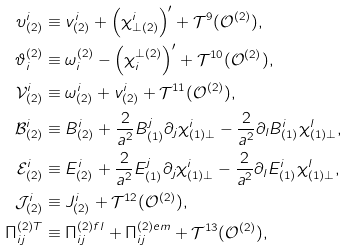Convert formula to latex. <formula><loc_0><loc_0><loc_500><loc_500>\upsilon _ { ( 2 ) } ^ { i } & \equiv v _ { ( 2 ) } ^ { i } + \left ( \chi _ { \bot ( 2 ) } ^ { i } \right ) ^ { \prime } + \mathcal { T } ^ { 9 } ( \mathcal { O } ^ { ( 2 ) } ) , \\ \vartheta _ { i } ^ { ( 2 ) } & \equiv \omega _ { i } ^ { ( 2 ) } - \left ( \chi _ { i } ^ { \bot ( 2 ) } \right ) ^ { \prime } + \mathcal { T } ^ { 1 0 } ( \mathcal { O } ^ { ( 2 ) } ) , \\ \mathcal { V } _ { ( 2 ) } ^ { i } & \equiv \omega _ { ( 2 ) } ^ { i } + v _ { ( 2 ) } ^ { i } + \mathcal { T } ^ { 1 1 } ( \mathcal { O } ^ { ( 2 ) } ) , \\ \mathcal { B } _ { ( 2 ) } ^ { i } & \equiv B _ { ( 2 ) } ^ { i } + \frac { 2 } { a ^ { 2 } } B _ { ( 1 ) } ^ { j } \partial _ { j } \chi _ { ( 1 ) \bot } ^ { i } - \frac { 2 } { a ^ { 2 } } \partial _ { l } B _ { ( 1 ) } ^ { i } \chi _ { ( 1 ) \bot } ^ { l } , \\ \mathcal { E } _ { ( 2 ) } ^ { i } & \equiv E _ { ( 2 ) } ^ { i } + \frac { 2 } { a ^ { 2 } } E _ { ( 1 ) } ^ { j } \partial _ { j } \chi _ { ( 1 ) \bot } ^ { i } - \frac { 2 } { a ^ { 2 } } \partial _ { l } E _ { ( 1 ) } ^ { i } \chi _ { ( 1 ) \bot } ^ { l } , \\ \mathcal { J } _ { ( 2 ) } ^ { i } & \equiv J _ { ( 2 ) } ^ { i } + \mathcal { T } ^ { 1 2 } ( \mathcal { O } ^ { ( 2 ) } ) , \\ \Pi _ { i j } ^ { ( 2 ) T } & \equiv \Pi _ { i j } ^ { ( 2 ) f l } + \Pi _ { i j } ^ { ( 2 ) e m } + \mathcal { T } ^ { 1 3 } ( \mathcal { O } ^ { ( 2 ) } ) ,</formula> 